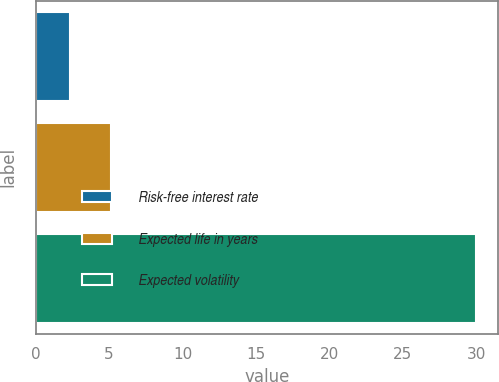<chart> <loc_0><loc_0><loc_500><loc_500><bar_chart><fcel>Risk-free interest rate<fcel>Expected life in years<fcel>Expected volatility<nl><fcel>2.33<fcel>5.1<fcel>30<nl></chart> 